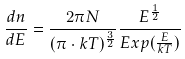Convert formula to latex. <formula><loc_0><loc_0><loc_500><loc_500>\frac { d n } { d E } = \frac { 2 \pi N } { ( \pi \cdot k T ) ^ { \frac { 3 } { 2 } } } \frac { E ^ { \frac { 1 } { 2 } } } { E x p ( \frac { E } { k T } ) }</formula> 